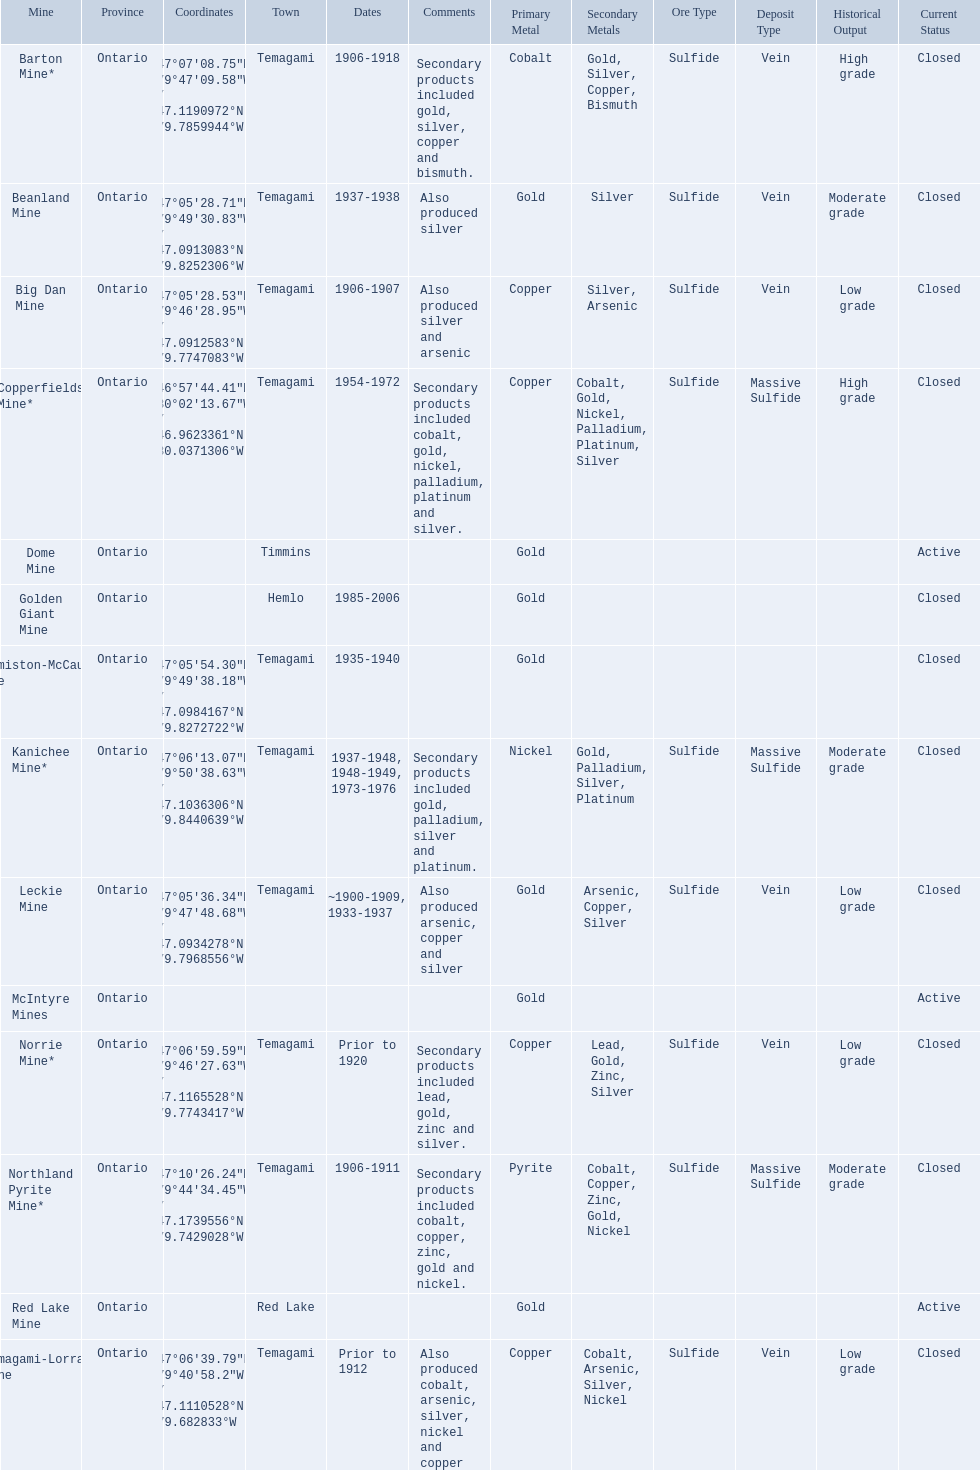What years was the golden giant mine open for? 1985-2006. What years was the beanland mine open? 1937-1938. Which of these two mines was open longer? Golden Giant Mine. 